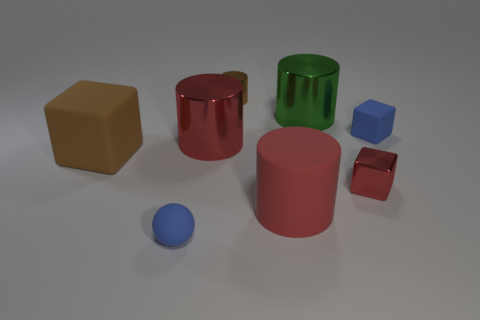Add 2 large brown objects. How many objects exist? 10 Subtract all cubes. How many objects are left? 5 Add 2 big red metallic things. How many big red metallic things are left? 3 Add 7 big brown matte spheres. How many big brown matte spheres exist? 7 Subtract 1 blue cubes. How many objects are left? 7 Subtract all tiny shiny blocks. Subtract all shiny cylinders. How many objects are left? 4 